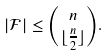Convert formula to latex. <formula><loc_0><loc_0><loc_500><loc_500>| \mathcal { F } | \leq { n \choose \lfloor \frac { n } { 2 } \rfloor } .</formula> 